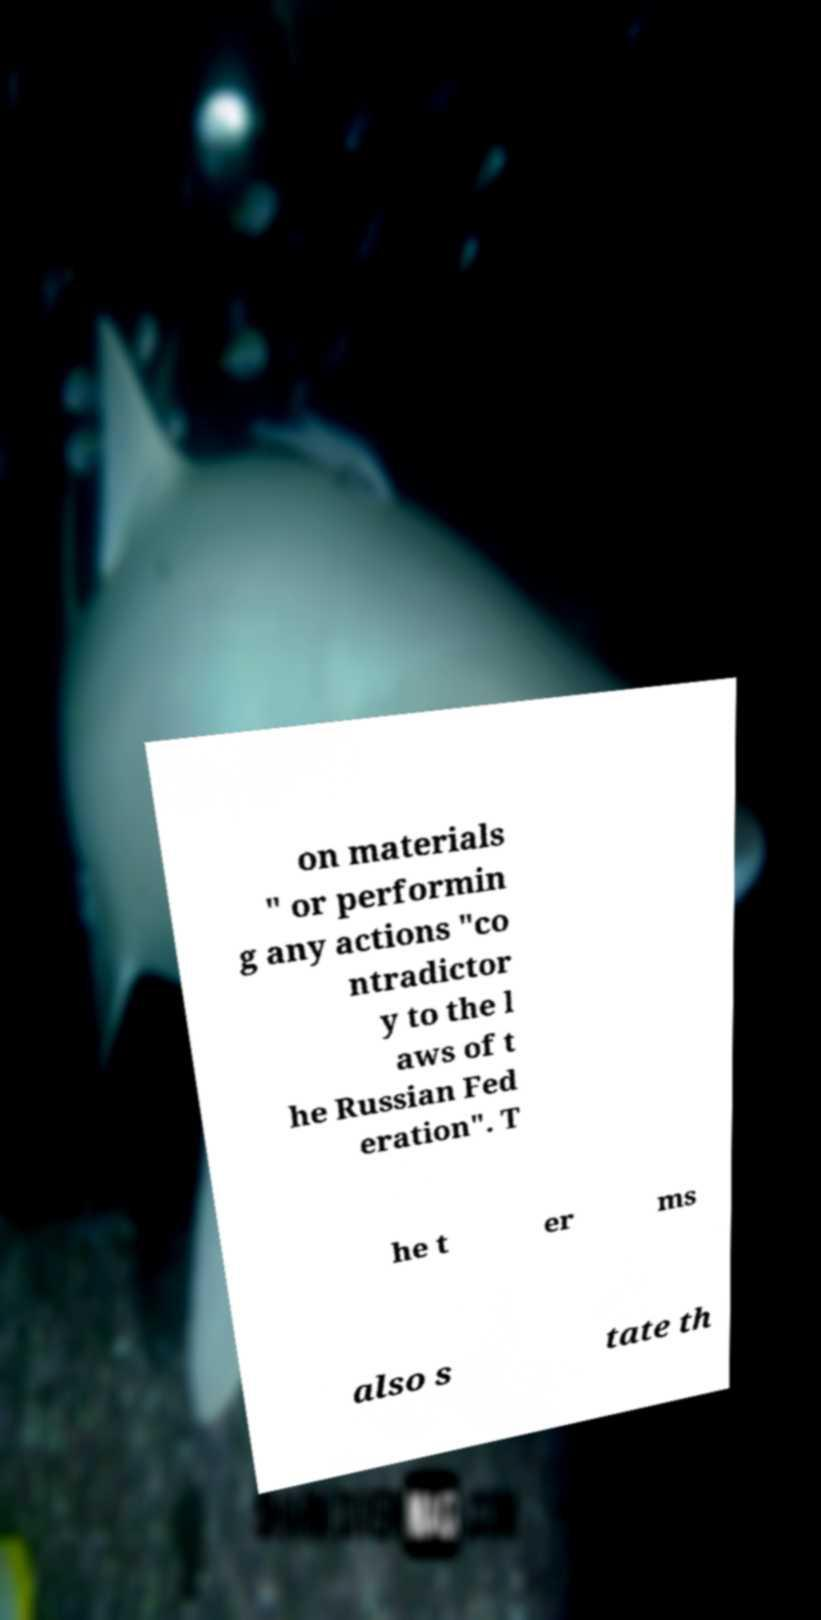Can you read and provide the text displayed in the image?This photo seems to have some interesting text. Can you extract and type it out for me? on materials " or performin g any actions "co ntradictor y to the l aws of t he Russian Fed eration". T he t er ms also s tate th 